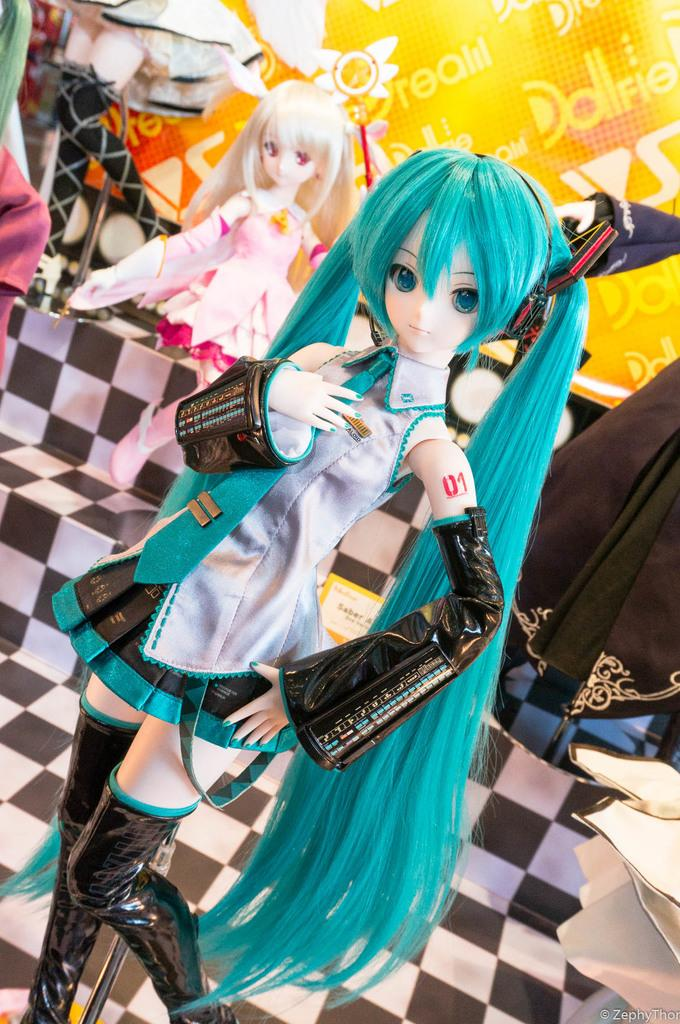What type of objects can be seen in the image? There are colorful dolls in the image. Can you describe the appearance of the dolls? The dolls are colorful, which suggests they have bright and vibrant colors. Are there any other objects or figures in the image besides the dolls? The image only shows colorful dolls, so there are no other objects or figures present. What type of competition is taking place between the dogs in the image? There are no dogs present in the image, so it is not possible to answer a question about a competition between them. 